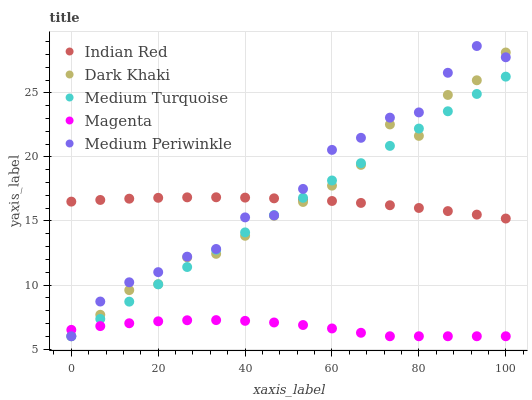Does Magenta have the minimum area under the curve?
Answer yes or no. Yes. Does Medium Periwinkle have the maximum area under the curve?
Answer yes or no. Yes. Does Medium Periwinkle have the minimum area under the curve?
Answer yes or no. No. Does Magenta have the maximum area under the curve?
Answer yes or no. No. Is Medium Turquoise the smoothest?
Answer yes or no. Yes. Is Medium Periwinkle the roughest?
Answer yes or no. Yes. Is Magenta the smoothest?
Answer yes or no. No. Is Magenta the roughest?
Answer yes or no. No. Does Dark Khaki have the lowest value?
Answer yes or no. Yes. Does Indian Red have the lowest value?
Answer yes or no. No. Does Medium Periwinkle have the highest value?
Answer yes or no. Yes. Does Magenta have the highest value?
Answer yes or no. No. Is Magenta less than Indian Red?
Answer yes or no. Yes. Is Indian Red greater than Magenta?
Answer yes or no. Yes. Does Indian Red intersect Medium Periwinkle?
Answer yes or no. Yes. Is Indian Red less than Medium Periwinkle?
Answer yes or no. No. Is Indian Red greater than Medium Periwinkle?
Answer yes or no. No. Does Magenta intersect Indian Red?
Answer yes or no. No. 